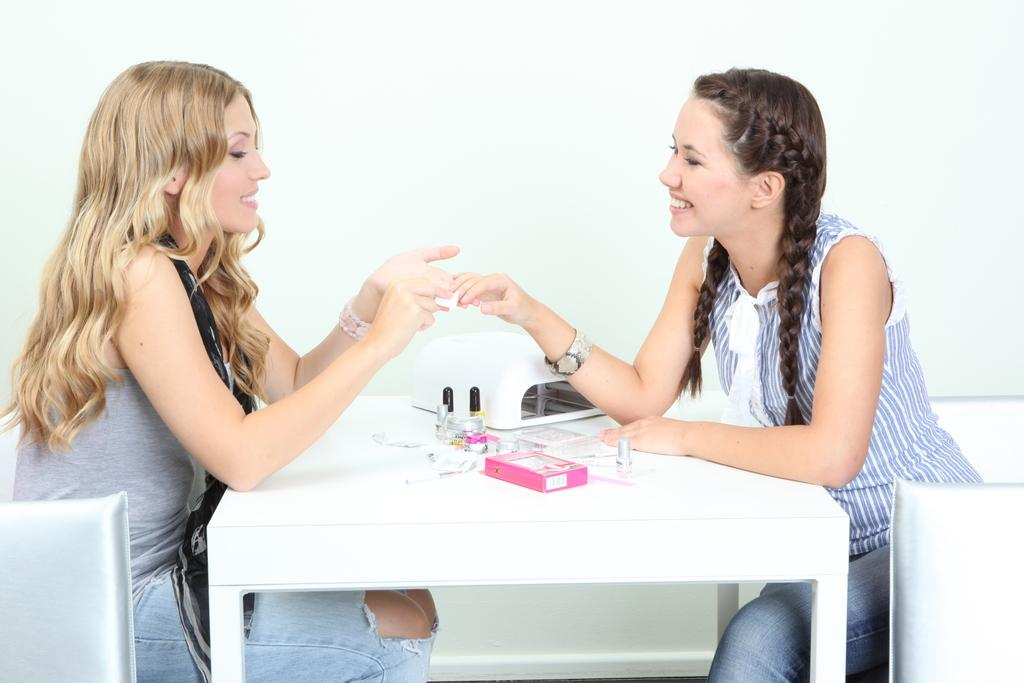How many women are in the image? There are two women in the image. What are the women doing in the image? The women are sitting on chairs. What is on the table in the image? There is a table in the image, and nail polish and a pink color cardboard box are present on the table. What type of silk material is draped over the women's chins in the image? There is no silk material draped over the women's chins in the image. Can you describe the women's toes in the image? There is no information about the women's toes in the image. 